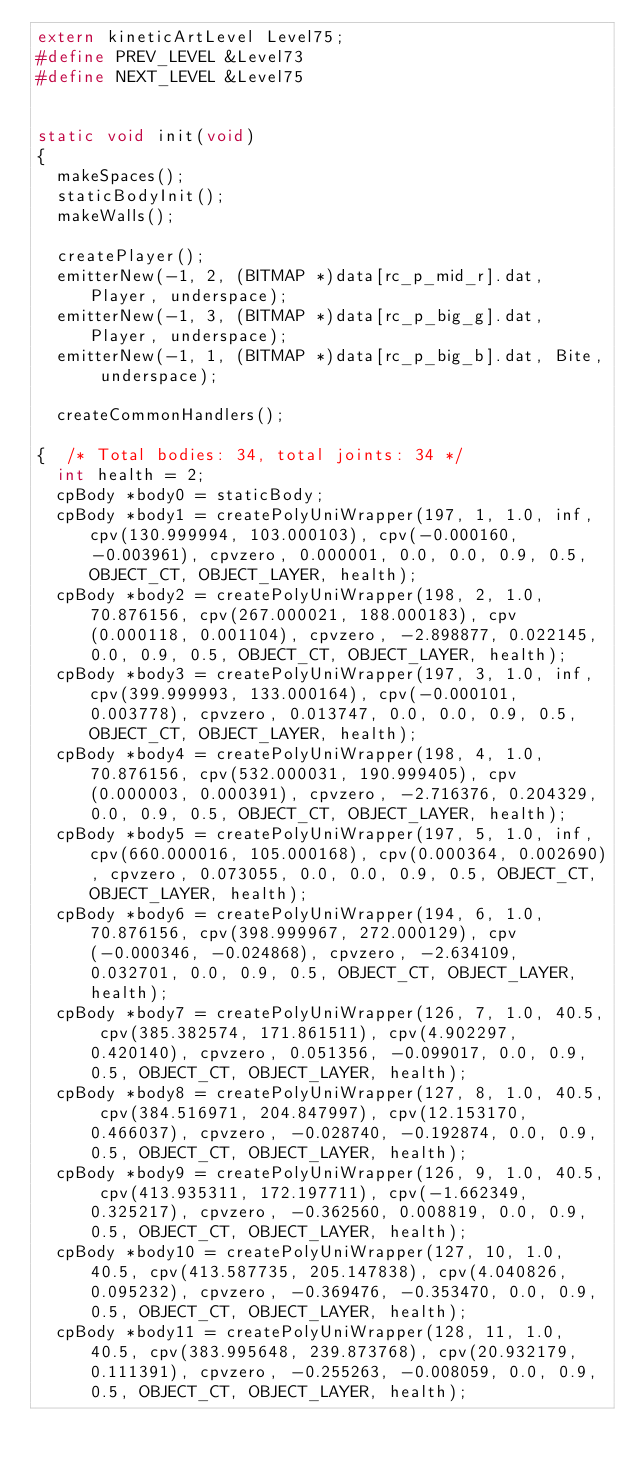Convert code to text. <code><loc_0><loc_0><loc_500><loc_500><_C_>extern kineticArtLevel Level75;
#define PREV_LEVEL &Level73
#define NEXT_LEVEL &Level75


static void init(void)
{
	makeSpaces();
	staticBodyInit();
	makeWalls();

	createPlayer();
	emitterNew(-1, 2, (BITMAP *)data[rc_p_mid_r].dat, Player, underspace);
	emitterNew(-1, 3, (BITMAP *)data[rc_p_big_g].dat, Player, underspace);
	emitterNew(-1, 1, (BITMAP *)data[rc_p_big_b].dat, Bite, underspace);

	createCommonHandlers();

{  /* Total bodies: 34, total joints: 34 */
	int health = 2;
	cpBody *body0 = staticBody;
	cpBody *body1 = createPolyUniWrapper(197, 1, 1.0, inf, cpv(130.999994, 103.000103), cpv(-0.000160, -0.003961), cpvzero, 0.000001, 0.0, 0.0, 0.9, 0.5, OBJECT_CT, OBJECT_LAYER, health);
	cpBody *body2 = createPolyUniWrapper(198, 2, 1.0, 70.876156, cpv(267.000021, 188.000183), cpv(0.000118, 0.001104), cpvzero, -2.898877, 0.022145, 0.0, 0.9, 0.5, OBJECT_CT, OBJECT_LAYER, health);
	cpBody *body3 = createPolyUniWrapper(197, 3, 1.0, inf, cpv(399.999993, 133.000164), cpv(-0.000101, 0.003778), cpvzero, 0.013747, 0.0, 0.0, 0.9, 0.5, OBJECT_CT, OBJECT_LAYER, health);
	cpBody *body4 = createPolyUniWrapper(198, 4, 1.0, 70.876156, cpv(532.000031, 190.999405), cpv(0.000003, 0.000391), cpvzero, -2.716376, 0.204329, 0.0, 0.9, 0.5, OBJECT_CT, OBJECT_LAYER, health);
	cpBody *body5 = createPolyUniWrapper(197, 5, 1.0, inf, cpv(660.000016, 105.000168), cpv(0.000364, 0.002690), cpvzero, 0.073055, 0.0, 0.0, 0.9, 0.5, OBJECT_CT, OBJECT_LAYER, health);
	cpBody *body6 = createPolyUniWrapper(194, 6, 1.0, 70.876156, cpv(398.999967, 272.000129), cpv(-0.000346, -0.024868), cpvzero, -2.634109, 0.032701, 0.0, 0.9, 0.5, OBJECT_CT, OBJECT_LAYER, health);
	cpBody *body7 = createPolyUniWrapper(126, 7, 1.0, 40.5, cpv(385.382574, 171.861511), cpv(4.902297, 0.420140), cpvzero, 0.051356, -0.099017, 0.0, 0.9, 0.5, OBJECT_CT, OBJECT_LAYER, health);
	cpBody *body8 = createPolyUniWrapper(127, 8, 1.0, 40.5, cpv(384.516971, 204.847997), cpv(12.153170, 0.466037), cpvzero, -0.028740, -0.192874, 0.0, 0.9, 0.5, OBJECT_CT, OBJECT_LAYER, health);
	cpBody *body9 = createPolyUniWrapper(126, 9, 1.0, 40.5, cpv(413.935311, 172.197711), cpv(-1.662349, 0.325217), cpvzero, -0.362560, 0.008819, 0.0, 0.9, 0.5, OBJECT_CT, OBJECT_LAYER, health);
	cpBody *body10 = createPolyUniWrapper(127, 10, 1.0, 40.5, cpv(413.587735, 205.147838), cpv(4.040826, 0.095232), cpvzero, -0.369476, -0.353470, 0.0, 0.9, 0.5, OBJECT_CT, OBJECT_LAYER, health);
	cpBody *body11 = createPolyUniWrapper(128, 11, 1.0, 40.5, cpv(383.995648, 239.873768), cpv(20.932179, 0.111391), cpvzero, -0.255263, -0.008059, 0.0, 0.9, 0.5, OBJECT_CT, OBJECT_LAYER, health);</code> 